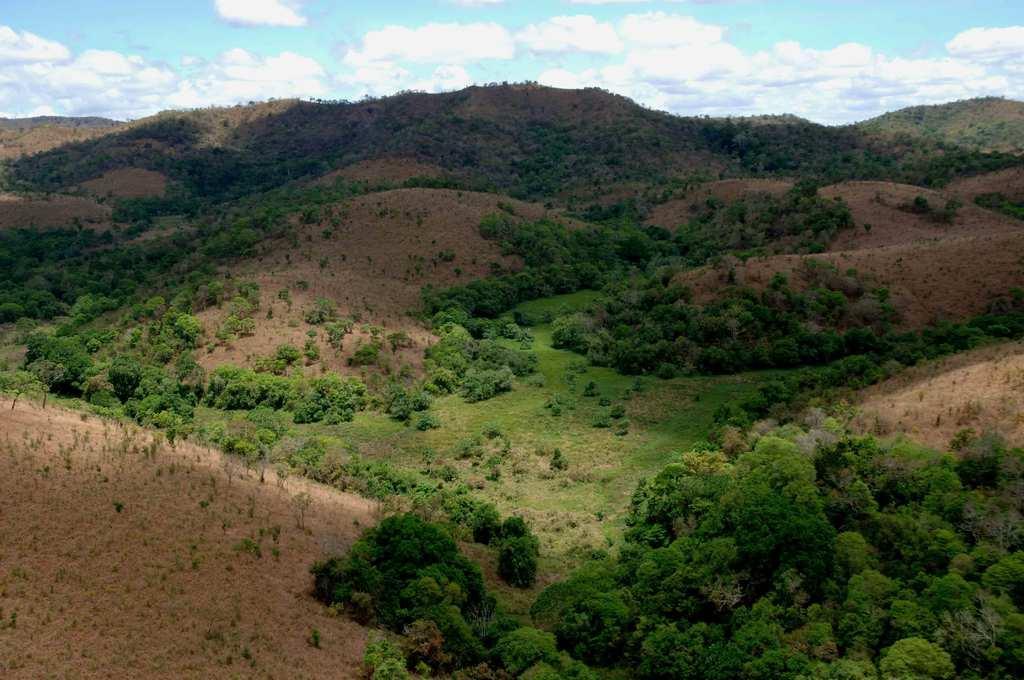Could you give a brief overview of what you see in this image? In this picture we can see trees, hills and the sky. 